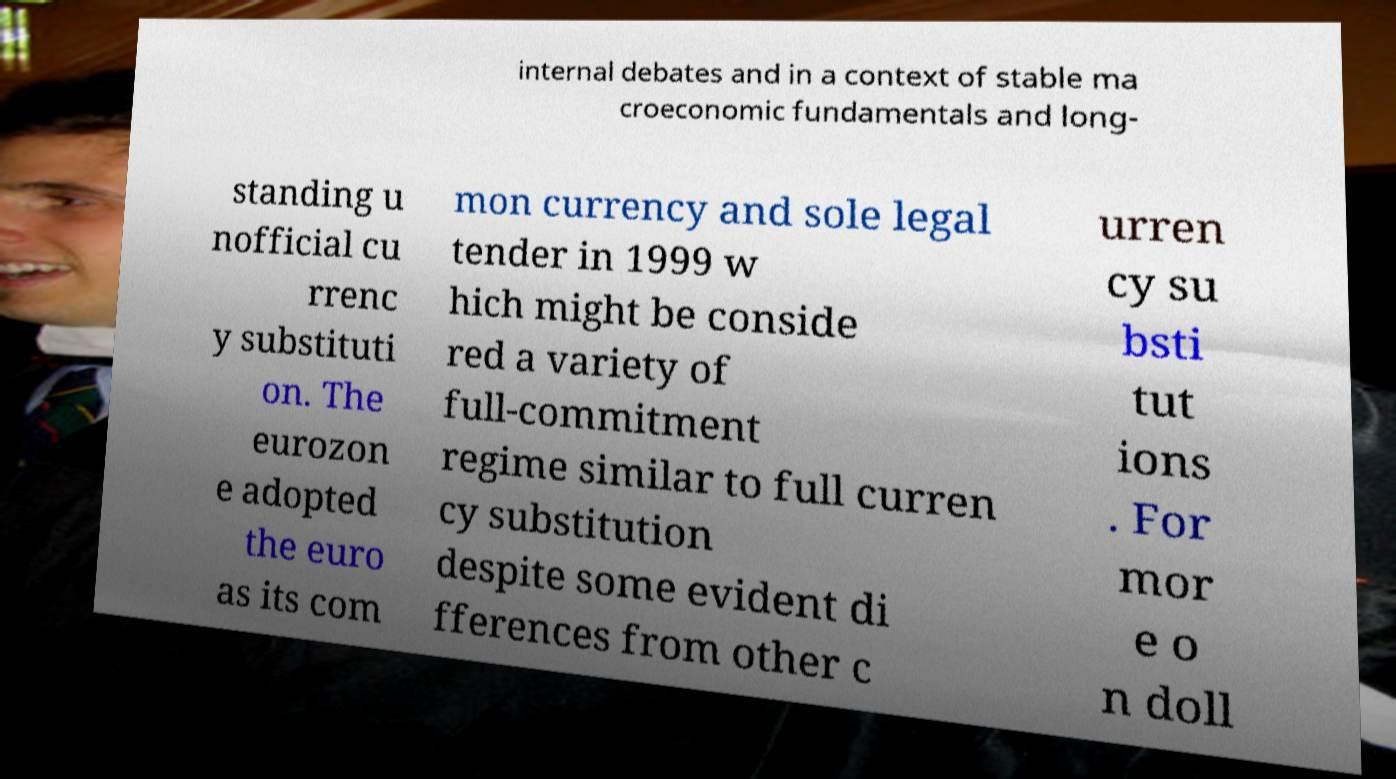I need the written content from this picture converted into text. Can you do that? internal debates and in a context of stable ma croeconomic fundamentals and long- standing u nofficial cu rrenc y substituti on. The eurozon e adopted the euro as its com mon currency and sole legal tender in 1999 w hich might be conside red a variety of full-commitment regime similar to full curren cy substitution despite some evident di fferences from other c urren cy su bsti tut ions . For mor e o n doll 